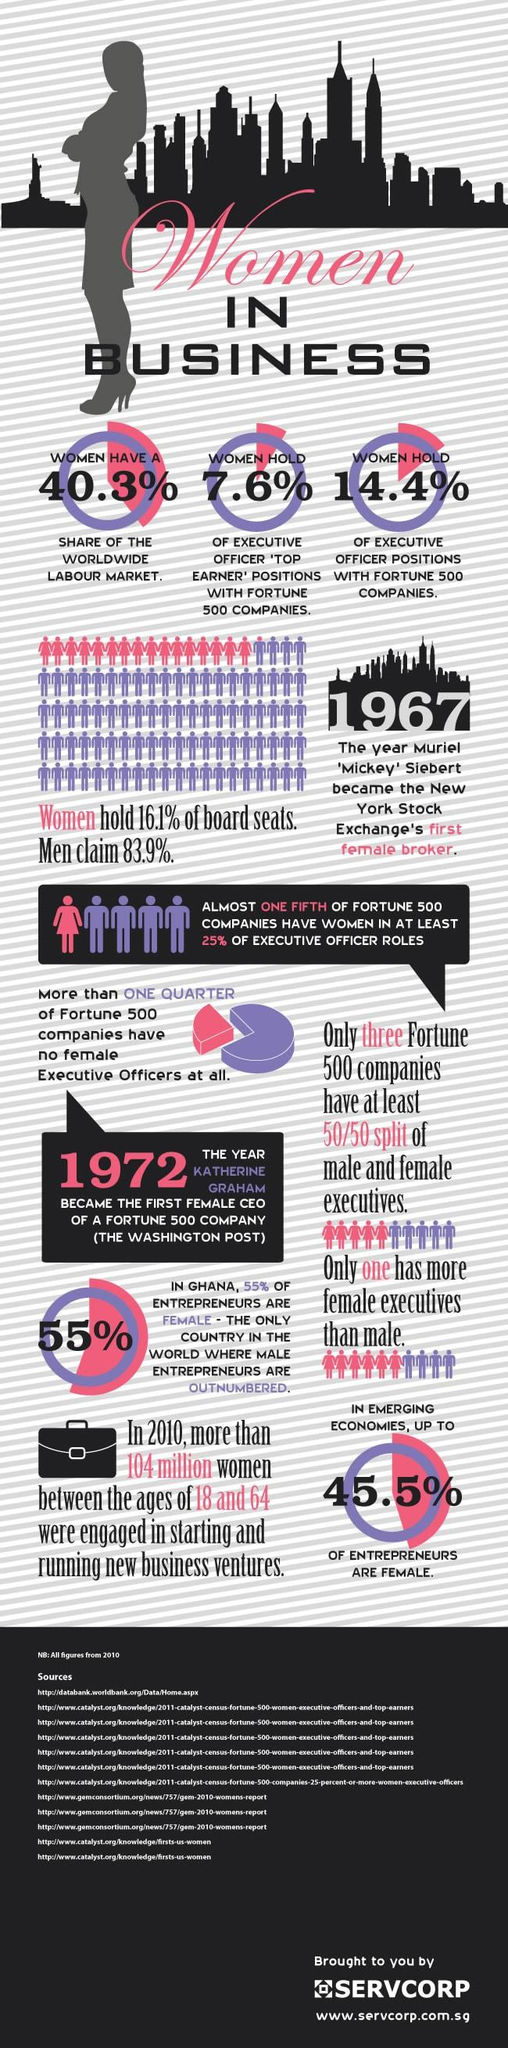Highlight a few significant elements in this photo. It took five years after the hiring of the first female broker for a Fortune 500 company to appoint its first female CEO. According to a study, only 7.6% of women hold executive officer top earner positions with Fortune 500 companies. According to a recent study, only 14.4% of women hold executive officer positions with Fortune 500 companies. In emerging economies, it was found that only 54.5% of entrepreneurs were female. According to recent data, women account for 40.3% of the worldwide labor market. 